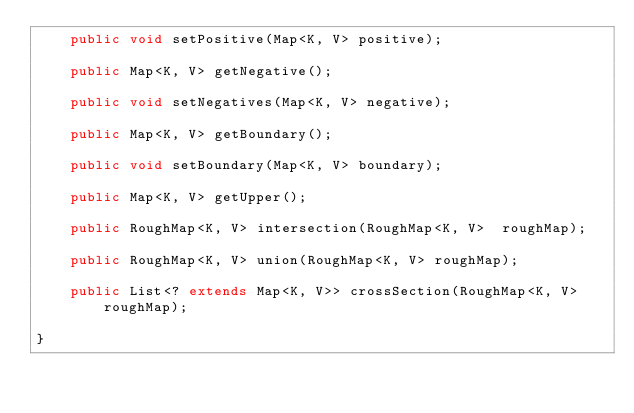Convert code to text. <code><loc_0><loc_0><loc_500><loc_500><_Java_>    public void setPositive(Map<K, V> positive);

    public Map<K, V> getNegative();

    public void setNegatives(Map<K, V> negative);

    public Map<K, V> getBoundary();

    public void setBoundary(Map<K, V> boundary);

    public Map<K, V> getUpper();

    public RoughMap<K, V> intersection(RoughMap<K, V>  roughMap);

    public RoughMap<K, V> union(RoughMap<K, V> roughMap);
    
    public List<? extends Map<K, V>> crossSection(RoughMap<K, V> roughMap);

}
</code> 